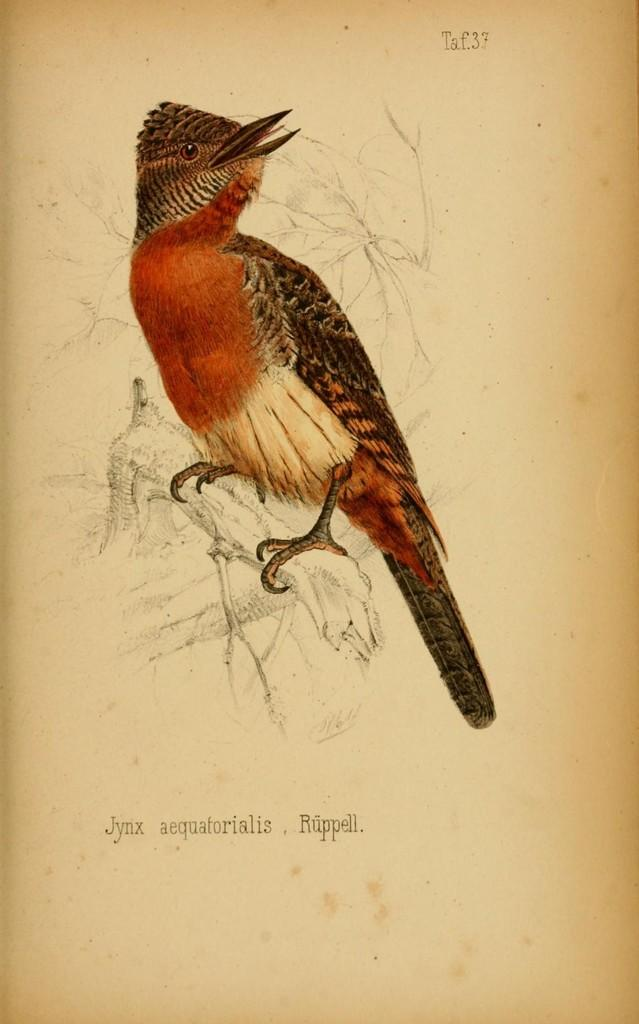What is depicted on the paper in the image? There is art on a paper in the image. How many trucks are visible in the image? There are no trucks present in the image. What type of tools might a carpenter use in the image? There is no carpenter or tools present in the image. 